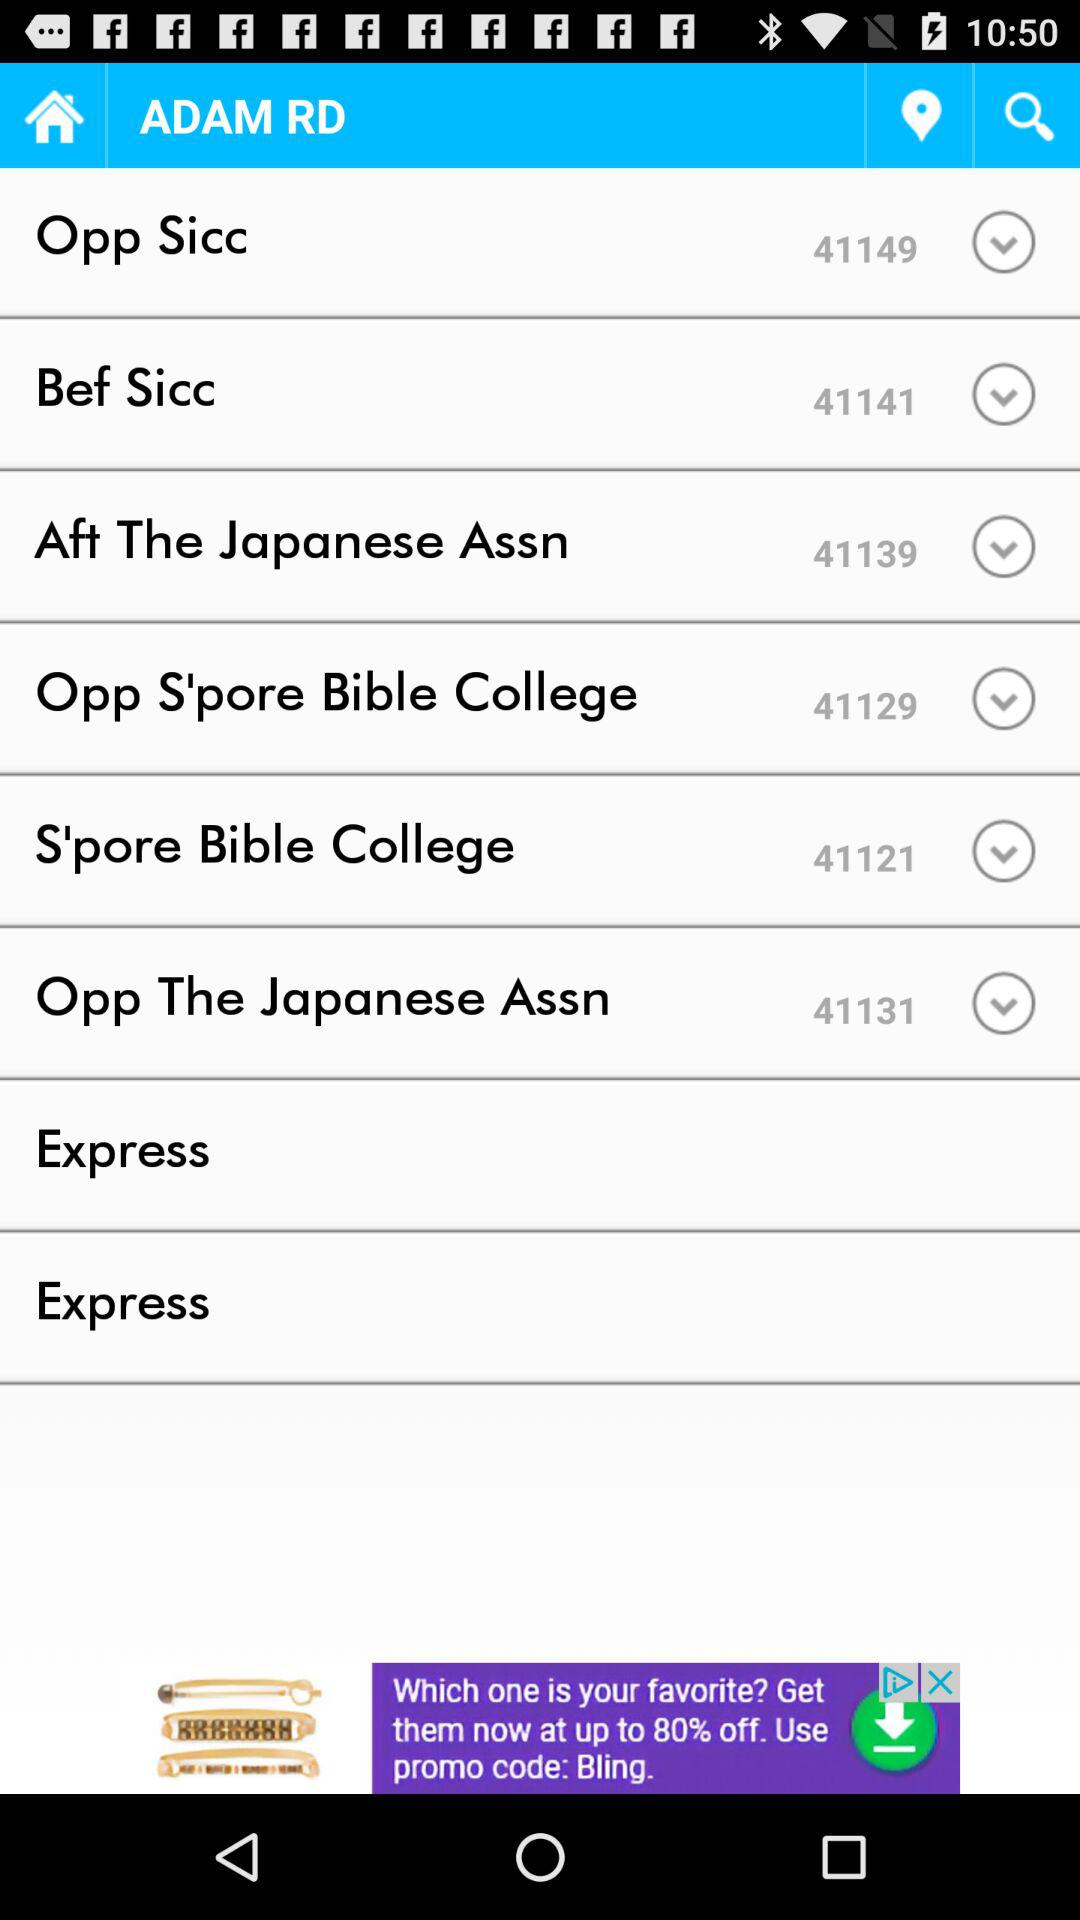What is the ID given for "Opp The Japanese Assn"? The ID given for "Opp The Japanese Assn" is 41131. 